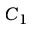Convert formula to latex. <formula><loc_0><loc_0><loc_500><loc_500>C _ { 1 }</formula> 